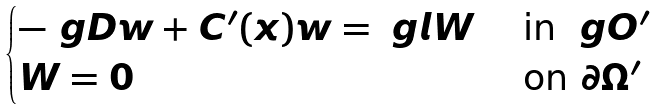Convert formula to latex. <formula><loc_0><loc_0><loc_500><loc_500>\begin{cases} - \ g D w + C ^ { \prime } ( x ) w = \ g l W & \text { in } \ g O ^ { \prime } \\ W = 0 & \text { on } \partial \Omega ^ { \prime } \end{cases}</formula> 